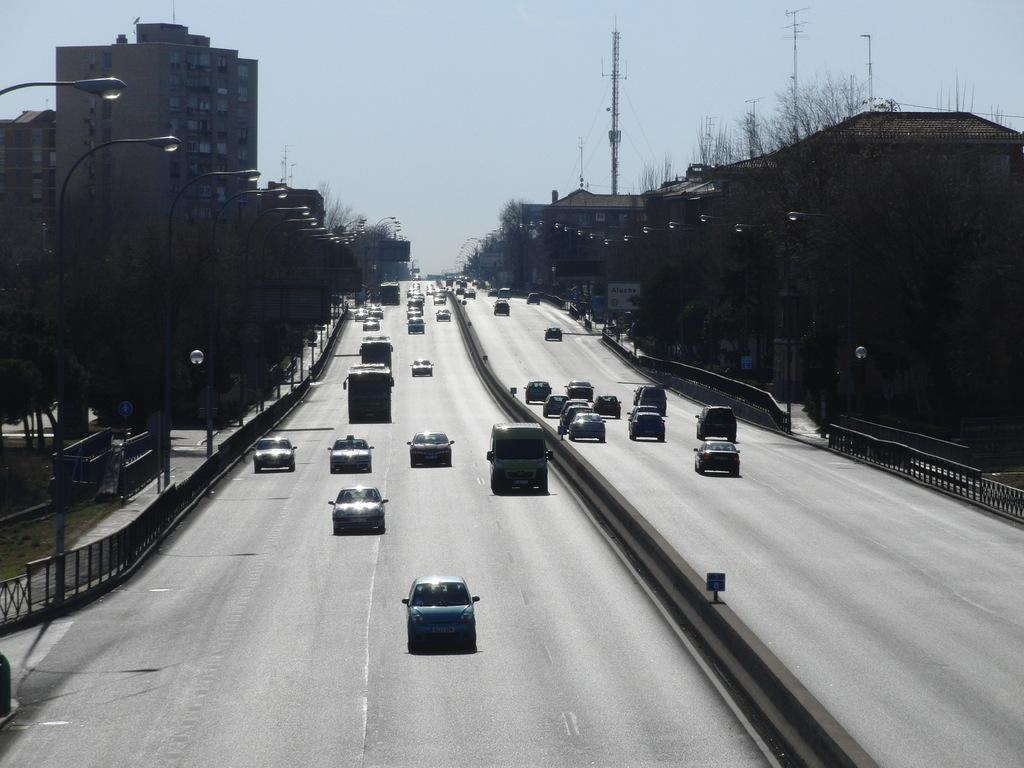What type of infrastructure is visible in the image? There are roads in the image. What is happening on the roads? There are vehicles moving on the roads. What safety features are present on the sides of the roads? There are railings on the sides of the roads. What structures are present to provide illumination at night? Street light poles are present on the sides of the roads. What type of vegetation is visible on the sides of the roads? Trees are visible on the sides of the roads. What type of man-made structures can be seen in the image? Buildings are present in the image. What is visible in the background of the image? The sky is visible in the background of the image. How many hands are visible holding the dock in the image? There is no dock present in the image, and therefore no hands holding it. 